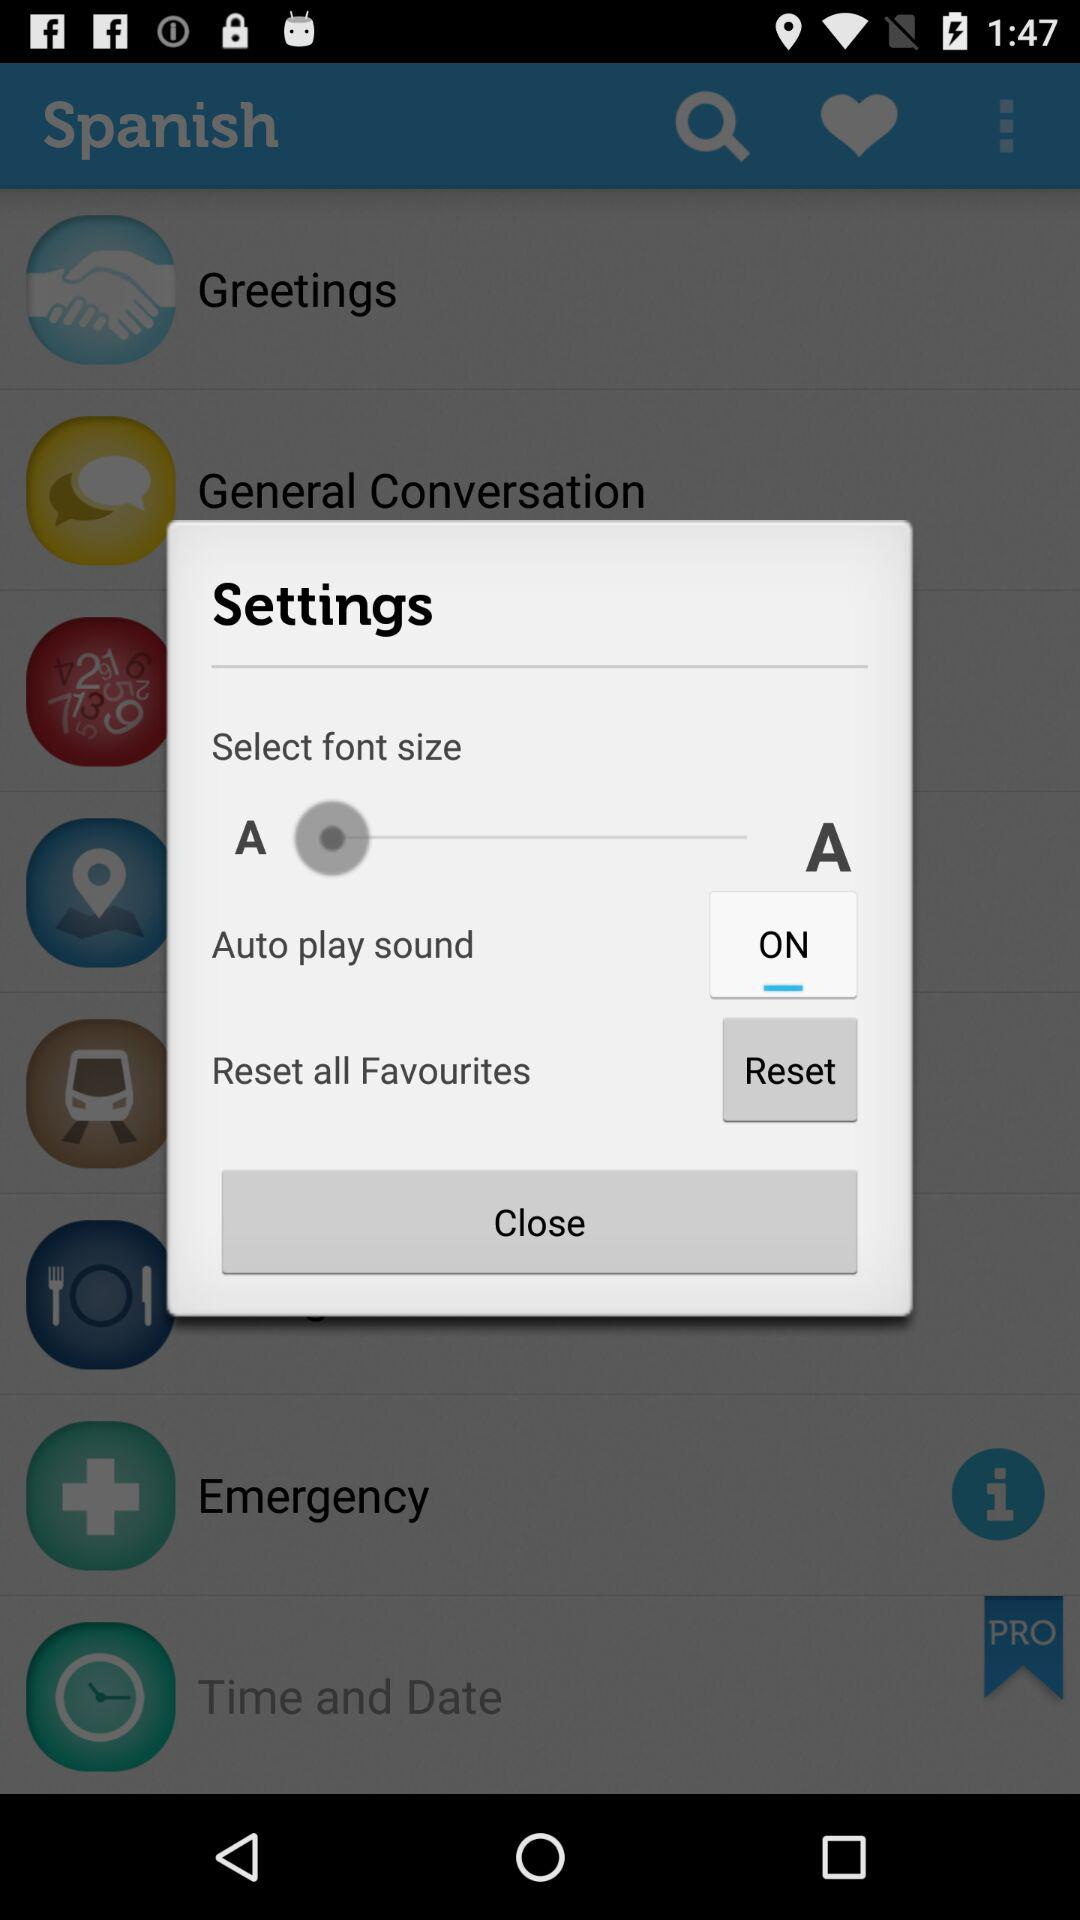What is the status of "Auto play sound" setting? The status of "Auto play sound" setting is "on". 